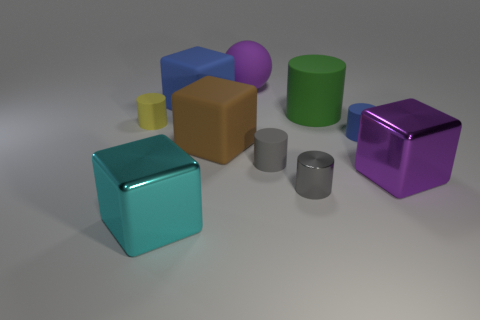How does the lighting in the image affect the appearance of the objects? The lighting in the image creates soft shadows and gentle reflections on the objects, enhancing the perception of their volume and texture. The matte surfaces, like the small gray cylinder, absorb light, while the shinier surfaces, like the large green cylinder, reflect more light, making them appear more vivid and tactile. 